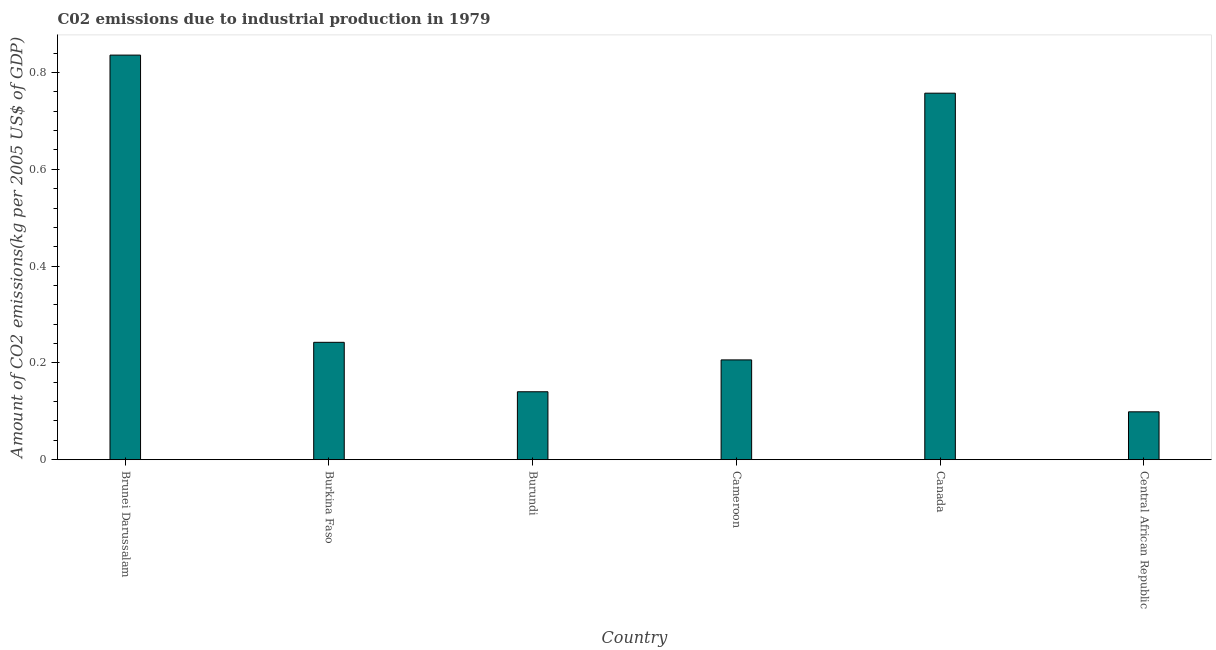Does the graph contain any zero values?
Offer a very short reply. No. What is the title of the graph?
Your answer should be very brief. C02 emissions due to industrial production in 1979. What is the label or title of the X-axis?
Give a very brief answer. Country. What is the label or title of the Y-axis?
Your response must be concise. Amount of CO2 emissions(kg per 2005 US$ of GDP). What is the amount of co2 emissions in Cameroon?
Your answer should be compact. 0.21. Across all countries, what is the maximum amount of co2 emissions?
Provide a short and direct response. 0.84. Across all countries, what is the minimum amount of co2 emissions?
Offer a terse response. 0.1. In which country was the amount of co2 emissions maximum?
Give a very brief answer. Brunei Darussalam. In which country was the amount of co2 emissions minimum?
Your answer should be very brief. Central African Republic. What is the sum of the amount of co2 emissions?
Your answer should be very brief. 2.28. What is the difference between the amount of co2 emissions in Burkina Faso and Canada?
Offer a very short reply. -0.52. What is the average amount of co2 emissions per country?
Keep it short and to the point. 0.38. What is the median amount of co2 emissions?
Keep it short and to the point. 0.22. What is the ratio of the amount of co2 emissions in Cameroon to that in Central African Republic?
Offer a terse response. 2.08. What is the difference between the highest and the second highest amount of co2 emissions?
Ensure brevity in your answer.  0.08. Is the sum of the amount of co2 emissions in Burkina Faso and Central African Republic greater than the maximum amount of co2 emissions across all countries?
Your response must be concise. No. What is the difference between the highest and the lowest amount of co2 emissions?
Make the answer very short. 0.74. How many bars are there?
Offer a terse response. 6. Are all the bars in the graph horizontal?
Ensure brevity in your answer.  No. What is the difference between two consecutive major ticks on the Y-axis?
Give a very brief answer. 0.2. Are the values on the major ticks of Y-axis written in scientific E-notation?
Ensure brevity in your answer.  No. What is the Amount of CO2 emissions(kg per 2005 US$ of GDP) in Brunei Darussalam?
Make the answer very short. 0.84. What is the Amount of CO2 emissions(kg per 2005 US$ of GDP) in Burkina Faso?
Provide a succinct answer. 0.24. What is the Amount of CO2 emissions(kg per 2005 US$ of GDP) of Burundi?
Offer a terse response. 0.14. What is the Amount of CO2 emissions(kg per 2005 US$ of GDP) of Cameroon?
Offer a very short reply. 0.21. What is the Amount of CO2 emissions(kg per 2005 US$ of GDP) in Canada?
Provide a short and direct response. 0.76. What is the Amount of CO2 emissions(kg per 2005 US$ of GDP) in Central African Republic?
Give a very brief answer. 0.1. What is the difference between the Amount of CO2 emissions(kg per 2005 US$ of GDP) in Brunei Darussalam and Burkina Faso?
Your answer should be very brief. 0.59. What is the difference between the Amount of CO2 emissions(kg per 2005 US$ of GDP) in Brunei Darussalam and Burundi?
Keep it short and to the point. 0.7. What is the difference between the Amount of CO2 emissions(kg per 2005 US$ of GDP) in Brunei Darussalam and Cameroon?
Offer a very short reply. 0.63. What is the difference between the Amount of CO2 emissions(kg per 2005 US$ of GDP) in Brunei Darussalam and Canada?
Give a very brief answer. 0.08. What is the difference between the Amount of CO2 emissions(kg per 2005 US$ of GDP) in Brunei Darussalam and Central African Republic?
Your answer should be compact. 0.74. What is the difference between the Amount of CO2 emissions(kg per 2005 US$ of GDP) in Burkina Faso and Burundi?
Keep it short and to the point. 0.1. What is the difference between the Amount of CO2 emissions(kg per 2005 US$ of GDP) in Burkina Faso and Cameroon?
Provide a succinct answer. 0.04. What is the difference between the Amount of CO2 emissions(kg per 2005 US$ of GDP) in Burkina Faso and Canada?
Make the answer very short. -0.51. What is the difference between the Amount of CO2 emissions(kg per 2005 US$ of GDP) in Burkina Faso and Central African Republic?
Provide a short and direct response. 0.14. What is the difference between the Amount of CO2 emissions(kg per 2005 US$ of GDP) in Burundi and Cameroon?
Provide a short and direct response. -0.07. What is the difference between the Amount of CO2 emissions(kg per 2005 US$ of GDP) in Burundi and Canada?
Give a very brief answer. -0.62. What is the difference between the Amount of CO2 emissions(kg per 2005 US$ of GDP) in Burundi and Central African Republic?
Give a very brief answer. 0.04. What is the difference between the Amount of CO2 emissions(kg per 2005 US$ of GDP) in Cameroon and Canada?
Offer a terse response. -0.55. What is the difference between the Amount of CO2 emissions(kg per 2005 US$ of GDP) in Cameroon and Central African Republic?
Ensure brevity in your answer.  0.11. What is the difference between the Amount of CO2 emissions(kg per 2005 US$ of GDP) in Canada and Central African Republic?
Offer a very short reply. 0.66. What is the ratio of the Amount of CO2 emissions(kg per 2005 US$ of GDP) in Brunei Darussalam to that in Burkina Faso?
Give a very brief answer. 3.45. What is the ratio of the Amount of CO2 emissions(kg per 2005 US$ of GDP) in Brunei Darussalam to that in Burundi?
Provide a succinct answer. 5.96. What is the ratio of the Amount of CO2 emissions(kg per 2005 US$ of GDP) in Brunei Darussalam to that in Cameroon?
Your response must be concise. 4.05. What is the ratio of the Amount of CO2 emissions(kg per 2005 US$ of GDP) in Brunei Darussalam to that in Canada?
Provide a succinct answer. 1.1. What is the ratio of the Amount of CO2 emissions(kg per 2005 US$ of GDP) in Brunei Darussalam to that in Central African Republic?
Give a very brief answer. 8.45. What is the ratio of the Amount of CO2 emissions(kg per 2005 US$ of GDP) in Burkina Faso to that in Burundi?
Ensure brevity in your answer.  1.73. What is the ratio of the Amount of CO2 emissions(kg per 2005 US$ of GDP) in Burkina Faso to that in Cameroon?
Your answer should be compact. 1.18. What is the ratio of the Amount of CO2 emissions(kg per 2005 US$ of GDP) in Burkina Faso to that in Canada?
Keep it short and to the point. 0.32. What is the ratio of the Amount of CO2 emissions(kg per 2005 US$ of GDP) in Burkina Faso to that in Central African Republic?
Your answer should be very brief. 2.45. What is the ratio of the Amount of CO2 emissions(kg per 2005 US$ of GDP) in Burundi to that in Cameroon?
Provide a succinct answer. 0.68. What is the ratio of the Amount of CO2 emissions(kg per 2005 US$ of GDP) in Burundi to that in Canada?
Make the answer very short. 0.18. What is the ratio of the Amount of CO2 emissions(kg per 2005 US$ of GDP) in Burundi to that in Central African Republic?
Ensure brevity in your answer.  1.42. What is the ratio of the Amount of CO2 emissions(kg per 2005 US$ of GDP) in Cameroon to that in Canada?
Ensure brevity in your answer.  0.27. What is the ratio of the Amount of CO2 emissions(kg per 2005 US$ of GDP) in Cameroon to that in Central African Republic?
Your answer should be very brief. 2.08. What is the ratio of the Amount of CO2 emissions(kg per 2005 US$ of GDP) in Canada to that in Central African Republic?
Make the answer very short. 7.65. 